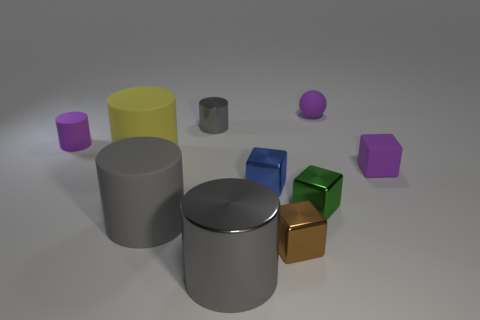Subtract all gray blocks. How many gray cylinders are left? 3 Subtract all green blocks. How many blocks are left? 3 Subtract all tiny matte cylinders. How many cylinders are left? 4 Subtract 2 cubes. How many cubes are left? 2 Subtract all blue cylinders. Subtract all green balls. How many cylinders are left? 5 Subtract all spheres. How many objects are left? 9 Subtract all gray rubber cylinders. Subtract all gray cylinders. How many objects are left? 6 Add 8 big gray objects. How many big gray objects are left? 10 Add 5 tiny yellow shiny things. How many tiny yellow shiny things exist? 5 Subtract 0 brown cylinders. How many objects are left? 10 